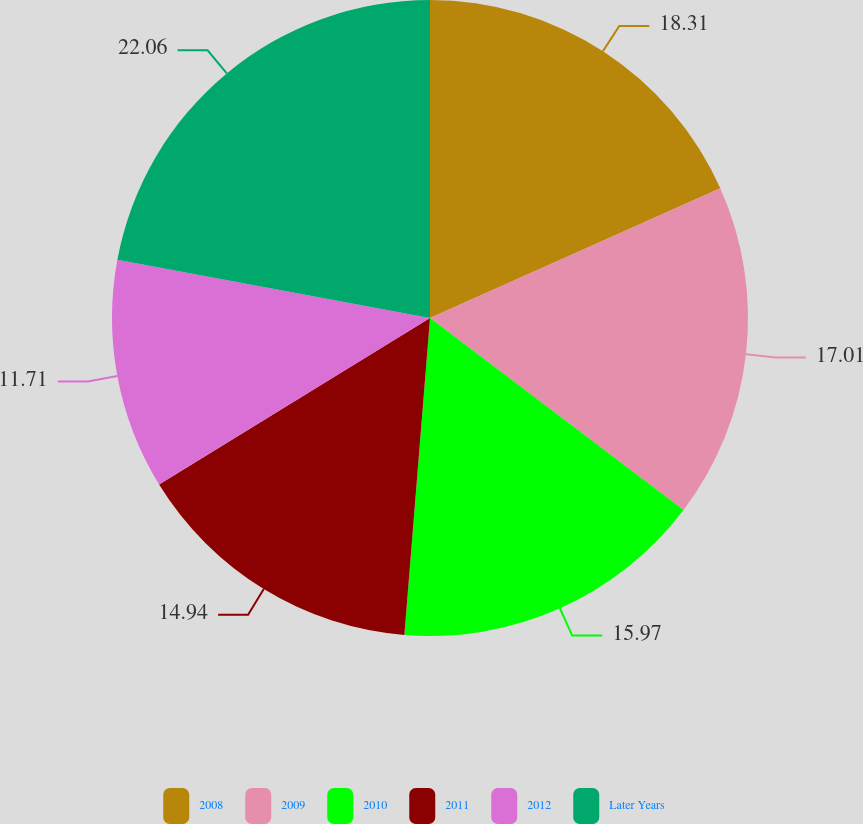Convert chart to OTSL. <chart><loc_0><loc_0><loc_500><loc_500><pie_chart><fcel>2008<fcel>2009<fcel>2010<fcel>2011<fcel>2012<fcel>Later Years<nl><fcel>18.31%<fcel>17.01%<fcel>15.97%<fcel>14.94%<fcel>11.71%<fcel>22.07%<nl></chart> 